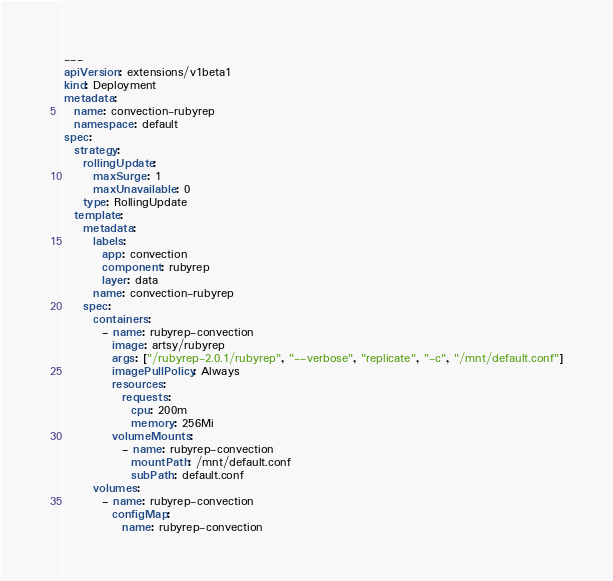<code> <loc_0><loc_0><loc_500><loc_500><_YAML_>---
apiVersion: extensions/v1beta1
kind: Deployment
metadata:
  name: convection-rubyrep
  namespace: default
spec:
  strategy:
    rollingUpdate:
      maxSurge: 1
      maxUnavailable: 0
    type: RollingUpdate
  template:
    metadata:
      labels:
        app: convection
        component: rubyrep
        layer: data
      name: convection-rubyrep
    spec:
      containers:
        - name: rubyrep-convection
          image: artsy/rubyrep
          args: ["/rubyrep-2.0.1/rubyrep", "--verbose", "replicate", "-c", "/mnt/default.conf"]
          imagePullPolicy: Always
          resources:
            requests:
              cpu: 200m
              memory: 256Mi
          volumeMounts:
            - name: rubyrep-convection
              mountPath: /mnt/default.conf
              subPath: default.conf
      volumes:
        - name: rubyrep-convection
          configMap:
            name: rubyrep-convection
</code> 